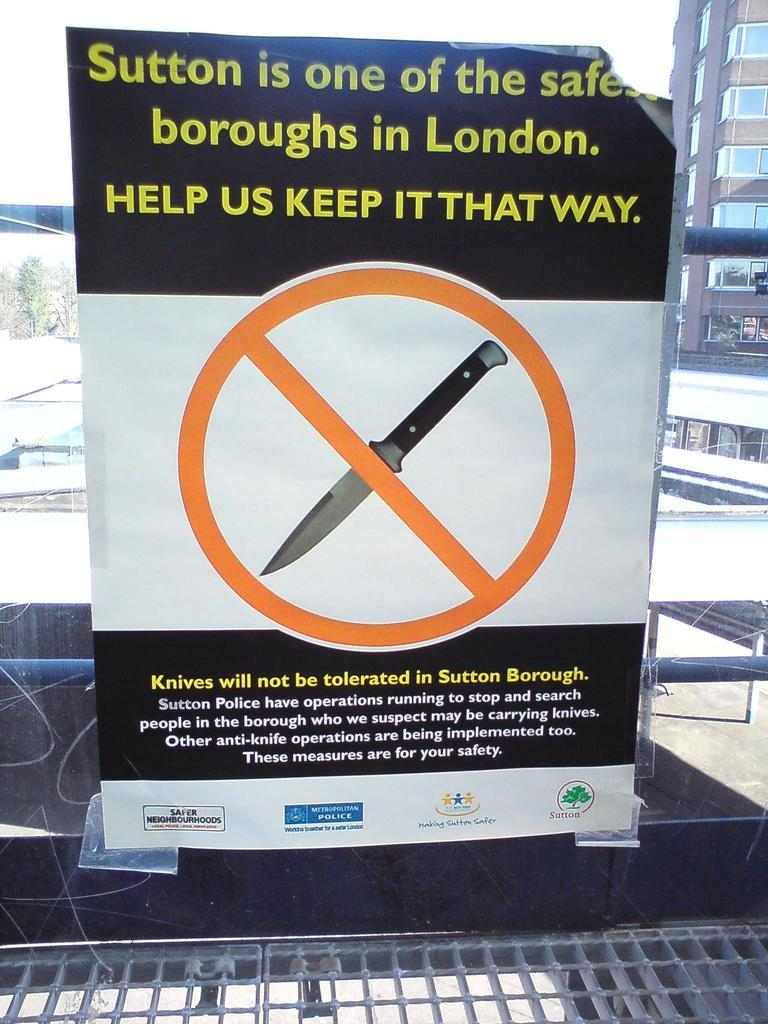<image>
Create a compact narrative representing the image presented. A sign in a window says "Sutton is one of the safe boroughs in London." 